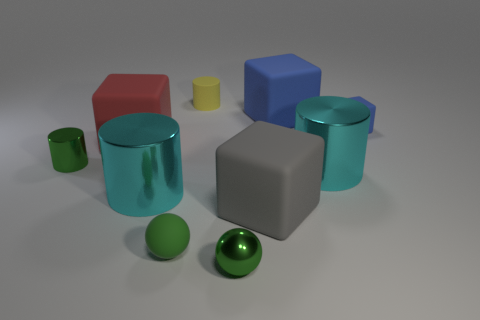Subtract all red matte cubes. How many cubes are left? 3 Subtract all green cylinders. How many cylinders are left? 3 Subtract 1 balls. How many balls are left? 1 Subtract all brown spheres. How many red blocks are left? 1 Subtract all big rubber objects. Subtract all tiny blue matte blocks. How many objects are left? 6 Add 8 tiny green metallic cylinders. How many tiny green metallic cylinders are left? 9 Add 10 small cyan metallic things. How many small cyan metallic things exist? 10 Subtract 1 yellow cylinders. How many objects are left? 9 Subtract all cubes. How many objects are left? 6 Subtract all brown cylinders. Subtract all blue balls. How many cylinders are left? 4 